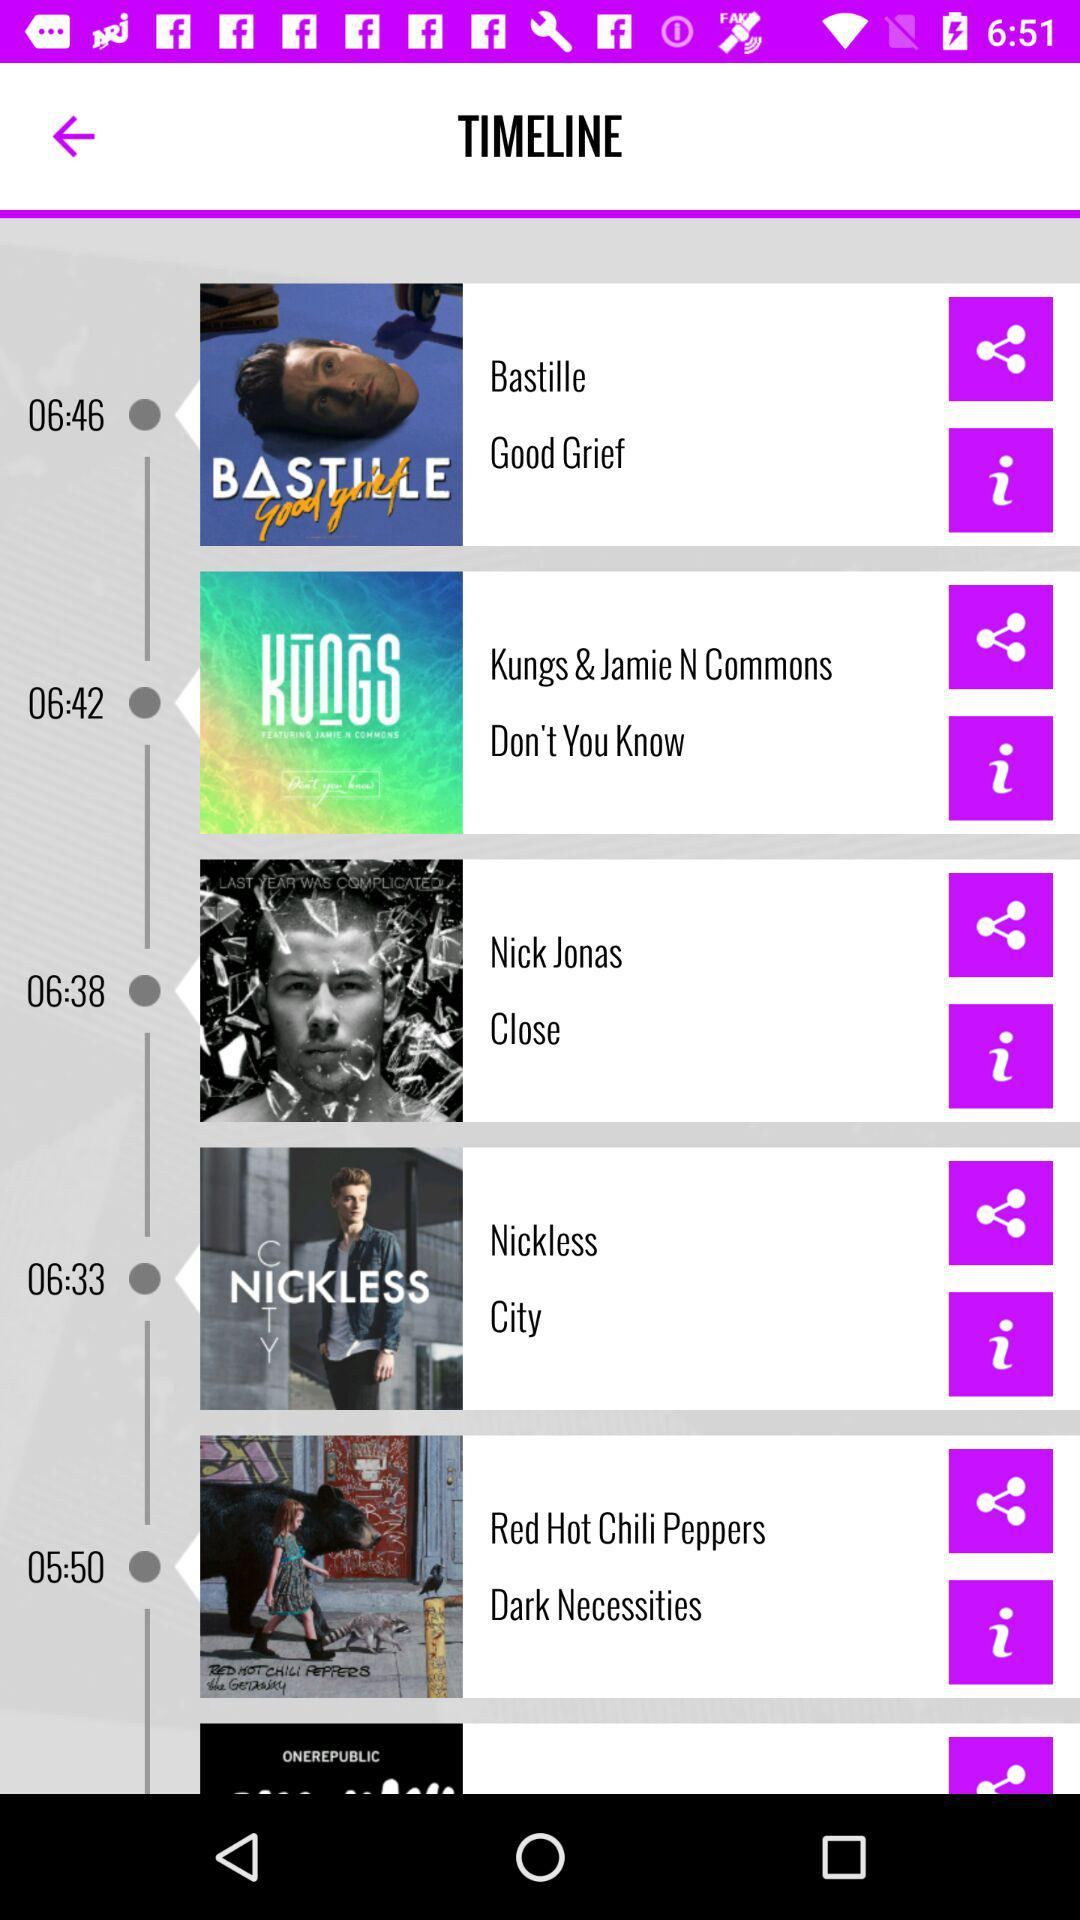Who is the singer of "Don't you know"? The singers of "Don't you know" are Kungs and Jamie N Commons. 